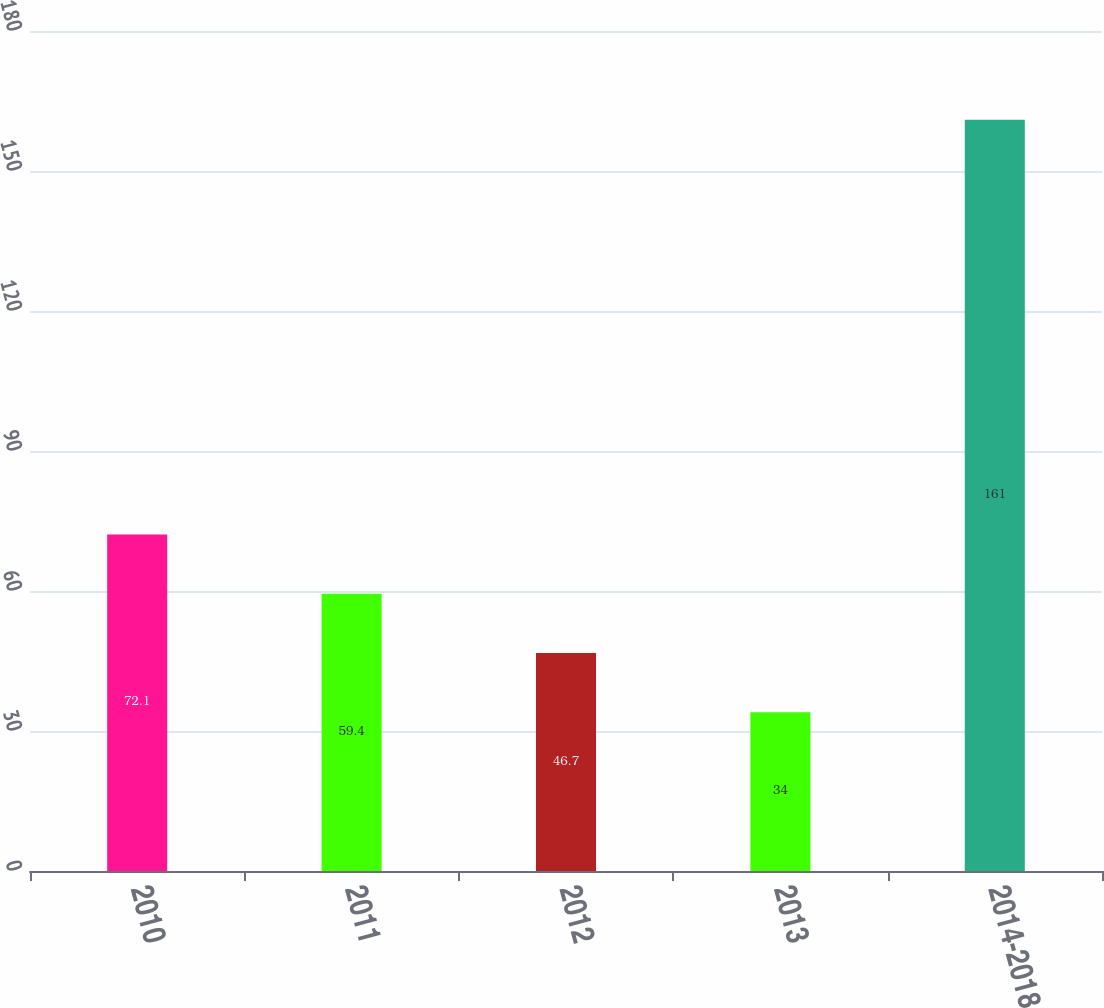<chart> <loc_0><loc_0><loc_500><loc_500><bar_chart><fcel>2010<fcel>2011<fcel>2012<fcel>2013<fcel>2014-2018<nl><fcel>72.1<fcel>59.4<fcel>46.7<fcel>34<fcel>161<nl></chart> 